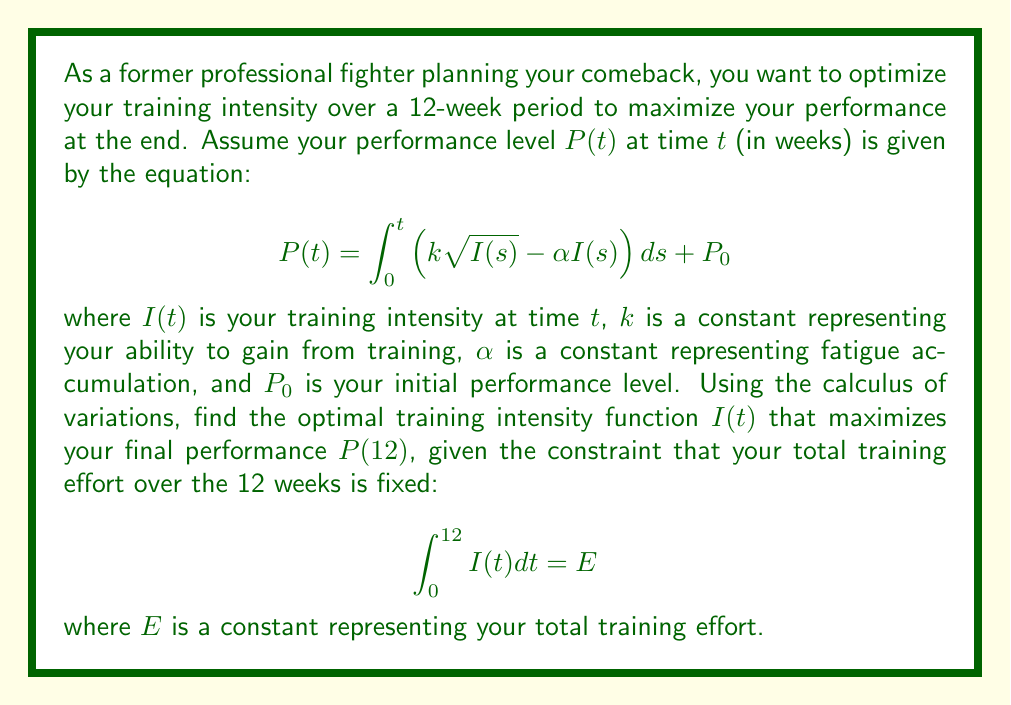Can you solve this math problem? To solve this problem, we'll use the Euler-Lagrange equation from the calculus of variations. Here's the step-by-step solution:

1) First, we need to formulate the functional to be maximized:

   $$J[I] = P(12) = \int_0^{12} \left(k\sqrt{I(t)} - \alpha I(t)\right) dt + P_0$$

2) We also have the isoperimetric constraint:

   $$\int_0^{12} I(t) dt = E$$

3) We form the augmented functional with a Lagrange multiplier $\lambda$:

   $$J^*[I] = \int_0^{12} \left(k\sqrt{I(t)} - \alpha I(t) + \lambda I(t)\right) dt + P_0$$

4) The integrand of this functional is our Lagrangian:

   $$L(I, t) = k\sqrt{I} - \alpha I + \lambda I$$

5) Apply the Euler-Lagrange equation:

   $$\frac{\partial L}{\partial I} - \frac{d}{dt}\left(\frac{\partial L}{\partial I'}\right) = 0$$

6) Simplify:

   $$\frac{k}{2\sqrt{I}} - \alpha + \lambda = 0$$

7) Solve for $I$:

   $$I(t) = \frac{k^2}{4(\alpha - \lambda)^2}$$

8) This is a constant function, independent of $t$. To find $\lambda$, we use the isoperimetric constraint:

   $$\int_0^{12} \frac{k^2}{4(\alpha - \lambda)^2} dt = E$$

9) Simplify:

   $$\frac{12k^2}{4(\alpha - \lambda)^2} = E$$

10) Solve for $\lambda$:

    $$\lambda = \alpha - \frac{k\sqrt{3}}{\sqrt{E}}$$

11) Substitute back into the expression for $I(t)$:

    $$I(t) = \frac{E}{12}$$

This constant training intensity maximizes the final performance $P(12)$ given the constraint on total training effort.
Answer: $I(t) = \frac{E}{12}$ 